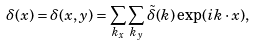Convert formula to latex. <formula><loc_0><loc_0><loc_500><loc_500>\delta ( { x } ) = \delta ( x , y ) = \sum _ { k _ { x } } \sum _ { k _ { y } } \tilde { \delta } ( { k } ) \exp ( i { k } \cdot { x } ) ,</formula> 